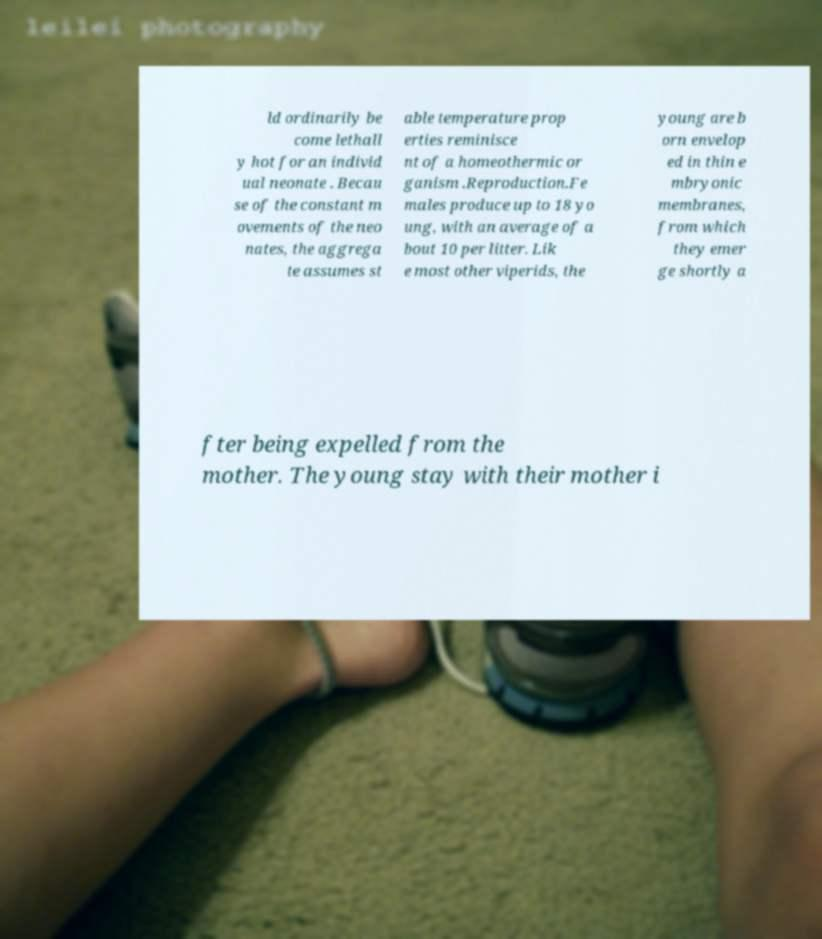Can you read and provide the text displayed in the image?This photo seems to have some interesting text. Can you extract and type it out for me? ld ordinarily be come lethall y hot for an individ ual neonate . Becau se of the constant m ovements of the neo nates, the aggrega te assumes st able temperature prop erties reminisce nt of a homeothermic or ganism .Reproduction.Fe males produce up to 18 yo ung, with an average of a bout 10 per litter. Lik e most other viperids, the young are b orn envelop ed in thin e mbryonic membranes, from which they emer ge shortly a fter being expelled from the mother. The young stay with their mother i 